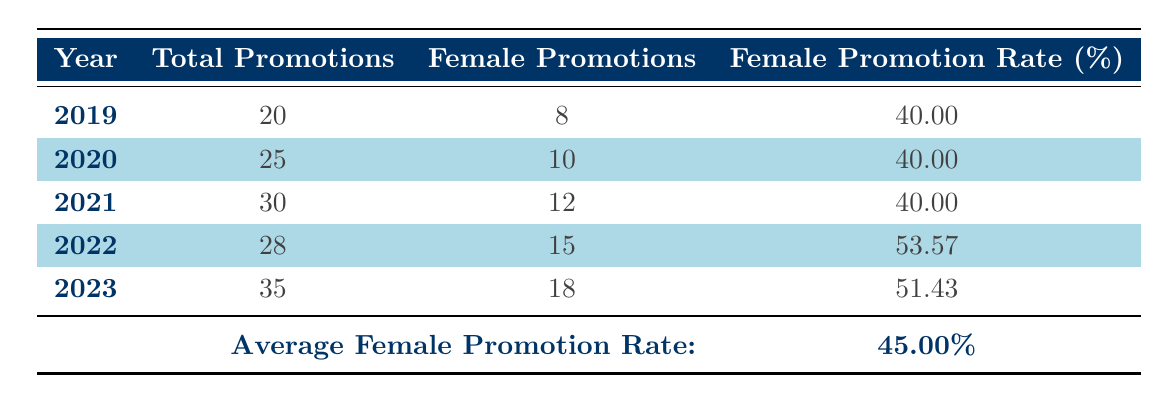What was the total number of promotions in 2020? Looking at the row for the year 2020, the value under the "Total Promotions" column is 25.
Answer: 25 In which year did the number of female promotions exceed the previous year? Comparing the "Female Promotions" values across the years, 15 in 2022 is greater than 12 in 2021. This indicates an increase from 2021 to 2022.
Answer: 2022 What is the average female promotion rate over the last five years? The average female promotion rate is stated in the last row of the table as 45.00%.
Answer: 45.00 Did the total number of promotions increase every year from 2019 to 2023? By analyzing the "Total Promotions" values, we see that the numbers are 20, 25, 30, 28, and 35. The value in 2022 (28) is lower than in 2021 (30), indicating a decrease.
Answer: No What was the female promotion rate for the year 2021? Referring to the column for "Female Promotion Rate" for the year 2021, the value is 40.00%.
Answer: 40.00% If we look at the years where female promotion rates were above the average, how many years fall into that category? The average female promotion rate is 45.00%. The years with rates above this are 2022 (53.57) and 2023 (51.43). Counting these gives us 2 years.
Answer: 2 What is the difference in female promotions between the years 2022 and 2023? The female promotions for 2022 is 15 and for 2023 is 18. Therefore, the difference is 18 - 15 = 3.
Answer: 3 Was the female promotion rate in 2022 higher than that in 2019? Comparing the values, the female promotion rate in 2022 is 53.57% while in 2019 it's 40.00%. Since 53.57% is greater than 40.00%, the statement is true.
Answer: Yes How many total promotions occurred from 2019 to 2023? To find the total, we sum the "Total Promotions" for each year: 20 + 25 + 30 + 28 + 35 = 138.
Answer: 138 